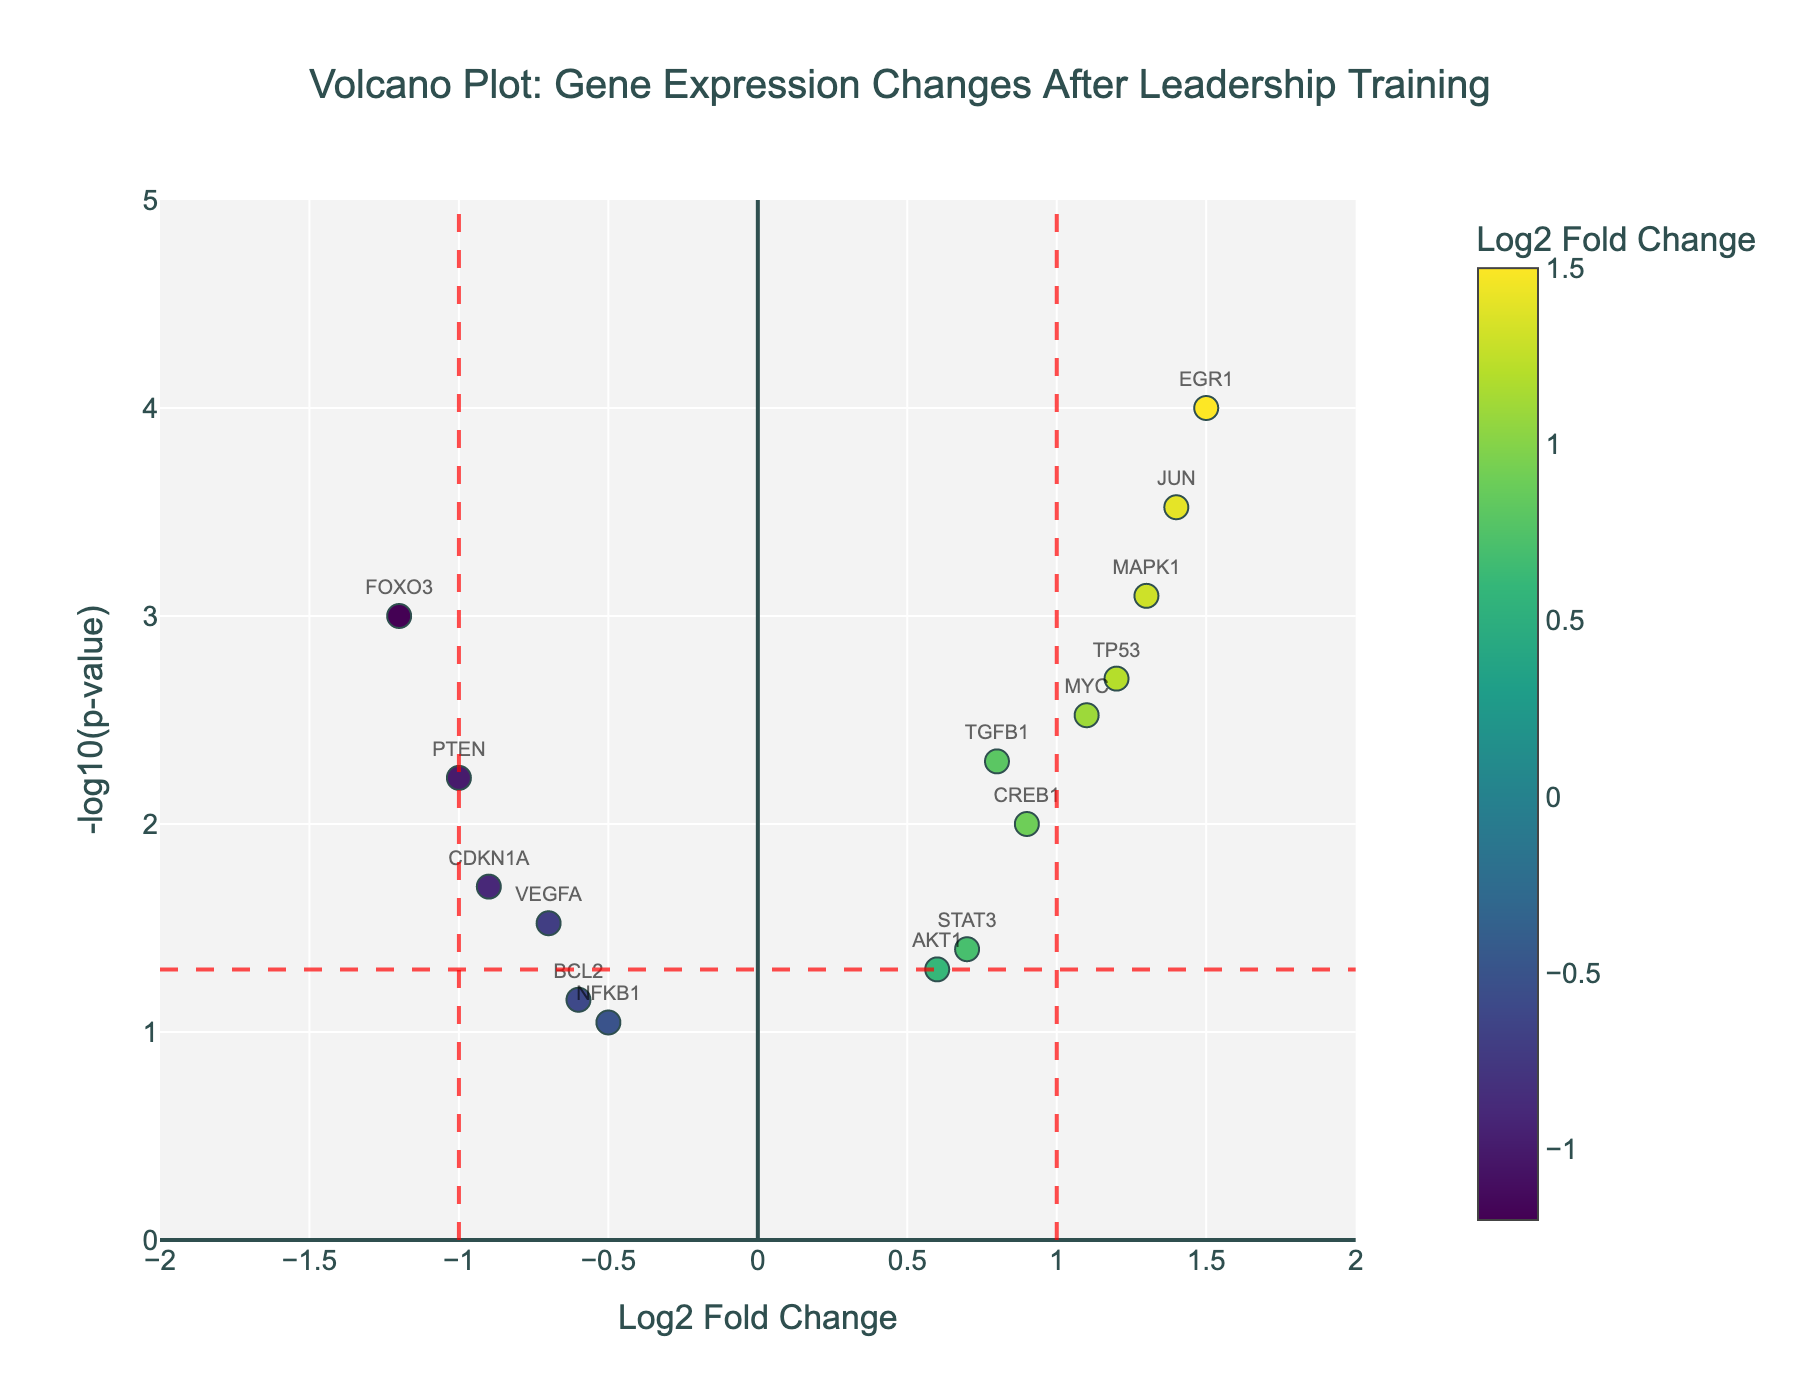How many genes have a significant p-value (p < 0.05) based on the plot? Count the number of points below the horizontal red dashed line, which represents the threshold of -log10(0.05). There are 12 such genes: FOXO3, TGFB1, EGR1, CDKN1A, MYC, MAPK1, CREB1, JUN, PTEN, TP53, VEGFA, and STAT3.
Answer: 12 Which gene has the highest Log2 Fold Change? Find the point that is farthest to the right on the x-axis. The gene is EGR1 with a Log2 Fold Change of 1.5.
Answer: EGR1 What is the Log2 Fold Change threshold indicated by the red vertical dashed lines? The red vertical dashed lines mark the thresholds for Log2 Fold Change values at -1 and 1.
Answer: -1 and 1 Which gene has the lowest p-value? The lowest p-value corresponds to the highest -log10(p-value). The gene with the highest y-axis value is EGR1.
Answer: EGR1 How many genes have a Log2 Fold Change greater than 1? Count the number of points to the right of the right red vertical dashed line at Log2 Fold Change = 1. There are 3 such genes: EGR1, MAPK1, and JUN.
Answer: 3 Which gene appears closest to the threshold for significance on the p-value axis? Identify the point that is nearest to the horizontal red dashed line at -log10(0.05). The gene is STAT3 with a -log10(p-value) slightly above the threshold.
Answer: STAT3 Which gene has the most negative Log2 Fold Change and is also statistically significant? Look for the point farthest to the left within the threshold for significance (below the red horizontal dashed line). The gene is FOXO3 with a Log2 Fold Change of -1.2 and a p-value of 0.001.
Answer: FOXO3 How many genes have both a significant p-value and a Log2 Fold Change above the threshold? Count the points located above the red dashed horizontal line and to the right of the red dashed vertical line. There are 8 such genes: EGR1, MYC, MAPK1, TP53, CREB1, JUN, TGFB1, and STAT3.
Answer: 8 